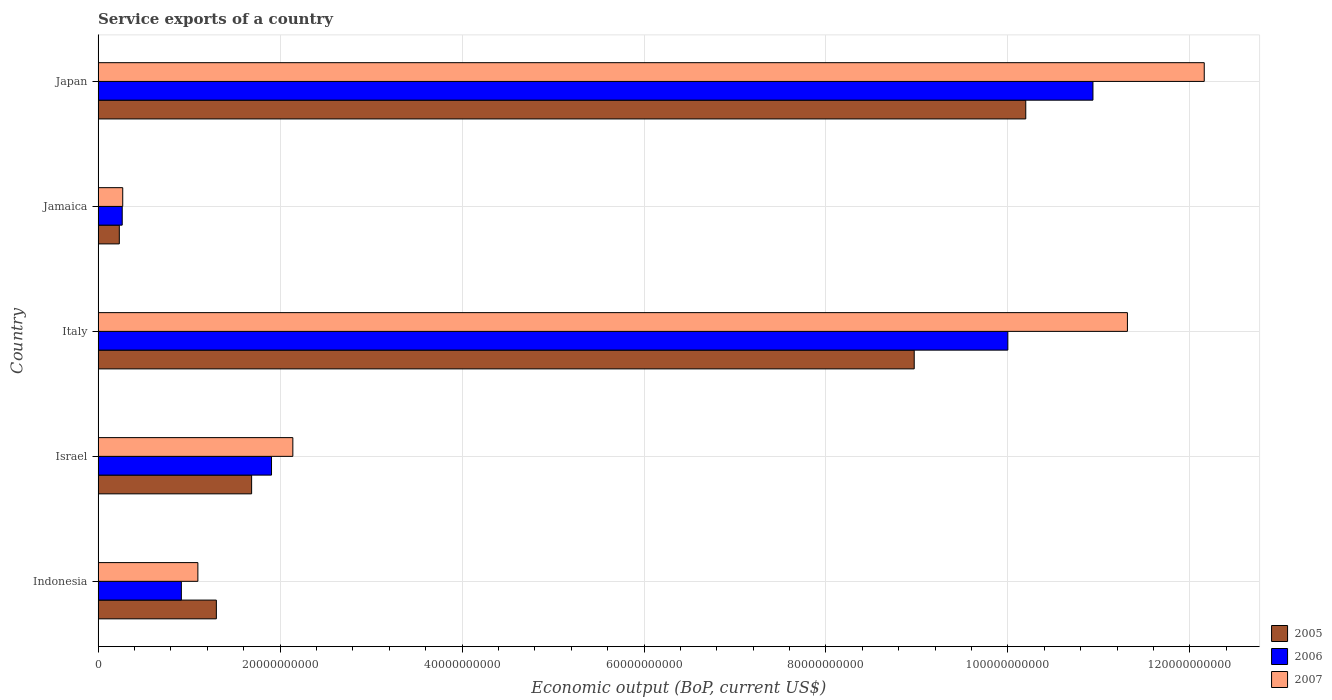How many different coloured bars are there?
Offer a very short reply. 3. Are the number of bars per tick equal to the number of legend labels?
Provide a short and direct response. Yes. Are the number of bars on each tick of the Y-axis equal?
Provide a succinct answer. Yes. How many bars are there on the 3rd tick from the top?
Give a very brief answer. 3. What is the label of the 2nd group of bars from the top?
Give a very brief answer. Jamaica. In how many cases, is the number of bars for a given country not equal to the number of legend labels?
Your answer should be very brief. 0. What is the service exports in 2005 in Japan?
Make the answer very short. 1.02e+11. Across all countries, what is the maximum service exports in 2005?
Ensure brevity in your answer.  1.02e+11. Across all countries, what is the minimum service exports in 2006?
Provide a succinct answer. 2.65e+09. In which country was the service exports in 2005 minimum?
Your response must be concise. Jamaica. What is the total service exports in 2005 in the graph?
Make the answer very short. 2.24e+11. What is the difference between the service exports in 2007 in Italy and that in Jamaica?
Offer a terse response. 1.10e+11. What is the difference between the service exports in 2006 in Israel and the service exports in 2007 in Italy?
Offer a very short reply. -9.41e+1. What is the average service exports in 2007 per country?
Your response must be concise. 5.40e+1. What is the difference between the service exports in 2006 and service exports in 2007 in Italy?
Offer a very short reply. -1.31e+1. What is the ratio of the service exports in 2005 in Indonesia to that in Israel?
Your answer should be very brief. 0.77. Is the service exports in 2006 in Israel less than that in Jamaica?
Offer a very short reply. No. Is the difference between the service exports in 2006 in Israel and Japan greater than the difference between the service exports in 2007 in Israel and Japan?
Give a very brief answer. Yes. What is the difference between the highest and the second highest service exports in 2007?
Your answer should be very brief. 8.44e+09. What is the difference between the highest and the lowest service exports in 2005?
Make the answer very short. 9.96e+1. In how many countries, is the service exports in 2005 greater than the average service exports in 2005 taken over all countries?
Keep it short and to the point. 2. Is the sum of the service exports in 2007 in Israel and Italy greater than the maximum service exports in 2006 across all countries?
Keep it short and to the point. Yes. What does the 3rd bar from the bottom in Japan represents?
Make the answer very short. 2007. Is it the case that in every country, the sum of the service exports in 2005 and service exports in 2007 is greater than the service exports in 2006?
Keep it short and to the point. Yes. How many bars are there?
Keep it short and to the point. 15. How many countries are there in the graph?
Ensure brevity in your answer.  5. What is the difference between two consecutive major ticks on the X-axis?
Make the answer very short. 2.00e+1. Are the values on the major ticks of X-axis written in scientific E-notation?
Ensure brevity in your answer.  No. Where does the legend appear in the graph?
Your answer should be very brief. Bottom right. How many legend labels are there?
Ensure brevity in your answer.  3. What is the title of the graph?
Your response must be concise. Service exports of a country. Does "1994" appear as one of the legend labels in the graph?
Your answer should be very brief. No. What is the label or title of the X-axis?
Provide a short and direct response. Economic output (BoP, current US$). What is the label or title of the Y-axis?
Your response must be concise. Country. What is the Economic output (BoP, current US$) of 2005 in Indonesia?
Your answer should be compact. 1.30e+1. What is the Economic output (BoP, current US$) in 2006 in Indonesia?
Give a very brief answer. 9.15e+09. What is the Economic output (BoP, current US$) of 2007 in Indonesia?
Ensure brevity in your answer.  1.10e+1. What is the Economic output (BoP, current US$) in 2005 in Israel?
Your answer should be very brief. 1.69e+1. What is the Economic output (BoP, current US$) of 2006 in Israel?
Give a very brief answer. 1.91e+1. What is the Economic output (BoP, current US$) of 2007 in Israel?
Offer a terse response. 2.14e+1. What is the Economic output (BoP, current US$) in 2005 in Italy?
Offer a very short reply. 8.97e+1. What is the Economic output (BoP, current US$) in 2006 in Italy?
Make the answer very short. 1.00e+11. What is the Economic output (BoP, current US$) in 2007 in Italy?
Keep it short and to the point. 1.13e+11. What is the Economic output (BoP, current US$) in 2005 in Jamaica?
Provide a succinct answer. 2.33e+09. What is the Economic output (BoP, current US$) in 2006 in Jamaica?
Provide a short and direct response. 2.65e+09. What is the Economic output (BoP, current US$) of 2007 in Jamaica?
Offer a very short reply. 2.71e+09. What is the Economic output (BoP, current US$) in 2005 in Japan?
Keep it short and to the point. 1.02e+11. What is the Economic output (BoP, current US$) in 2006 in Japan?
Your response must be concise. 1.09e+11. What is the Economic output (BoP, current US$) in 2007 in Japan?
Give a very brief answer. 1.22e+11. Across all countries, what is the maximum Economic output (BoP, current US$) of 2005?
Make the answer very short. 1.02e+11. Across all countries, what is the maximum Economic output (BoP, current US$) in 2006?
Your response must be concise. 1.09e+11. Across all countries, what is the maximum Economic output (BoP, current US$) of 2007?
Make the answer very short. 1.22e+11. Across all countries, what is the minimum Economic output (BoP, current US$) in 2005?
Your response must be concise. 2.33e+09. Across all countries, what is the minimum Economic output (BoP, current US$) of 2006?
Provide a succinct answer. 2.65e+09. Across all countries, what is the minimum Economic output (BoP, current US$) of 2007?
Make the answer very short. 2.71e+09. What is the total Economic output (BoP, current US$) in 2005 in the graph?
Your answer should be very brief. 2.24e+11. What is the total Economic output (BoP, current US$) in 2006 in the graph?
Provide a succinct answer. 2.40e+11. What is the total Economic output (BoP, current US$) in 2007 in the graph?
Provide a succinct answer. 2.70e+11. What is the difference between the Economic output (BoP, current US$) in 2005 in Indonesia and that in Israel?
Offer a terse response. -3.88e+09. What is the difference between the Economic output (BoP, current US$) in 2006 in Indonesia and that in Israel?
Keep it short and to the point. -9.91e+09. What is the difference between the Economic output (BoP, current US$) in 2007 in Indonesia and that in Israel?
Your answer should be very brief. -1.04e+1. What is the difference between the Economic output (BoP, current US$) of 2005 in Indonesia and that in Italy?
Provide a succinct answer. -7.67e+1. What is the difference between the Economic output (BoP, current US$) in 2006 in Indonesia and that in Italy?
Keep it short and to the point. -9.08e+1. What is the difference between the Economic output (BoP, current US$) in 2007 in Indonesia and that in Italy?
Your response must be concise. -1.02e+11. What is the difference between the Economic output (BoP, current US$) of 2005 in Indonesia and that in Jamaica?
Make the answer very short. 1.07e+1. What is the difference between the Economic output (BoP, current US$) of 2006 in Indonesia and that in Jamaica?
Make the answer very short. 6.50e+09. What is the difference between the Economic output (BoP, current US$) of 2007 in Indonesia and that in Jamaica?
Provide a succinct answer. 8.26e+09. What is the difference between the Economic output (BoP, current US$) in 2005 in Indonesia and that in Japan?
Offer a very short reply. -8.90e+1. What is the difference between the Economic output (BoP, current US$) of 2006 in Indonesia and that in Japan?
Give a very brief answer. -1.00e+11. What is the difference between the Economic output (BoP, current US$) in 2007 in Indonesia and that in Japan?
Provide a succinct answer. -1.11e+11. What is the difference between the Economic output (BoP, current US$) in 2005 in Israel and that in Italy?
Ensure brevity in your answer.  -7.28e+1. What is the difference between the Economic output (BoP, current US$) of 2006 in Israel and that in Italy?
Keep it short and to the point. -8.09e+1. What is the difference between the Economic output (BoP, current US$) of 2007 in Israel and that in Italy?
Give a very brief answer. -9.17e+1. What is the difference between the Economic output (BoP, current US$) of 2005 in Israel and that in Jamaica?
Your answer should be compact. 1.45e+1. What is the difference between the Economic output (BoP, current US$) in 2006 in Israel and that in Jamaica?
Your answer should be compact. 1.64e+1. What is the difference between the Economic output (BoP, current US$) in 2007 in Israel and that in Jamaica?
Offer a very short reply. 1.87e+1. What is the difference between the Economic output (BoP, current US$) of 2005 in Israel and that in Japan?
Make the answer very short. -8.51e+1. What is the difference between the Economic output (BoP, current US$) in 2006 in Israel and that in Japan?
Make the answer very short. -9.03e+1. What is the difference between the Economic output (BoP, current US$) of 2007 in Israel and that in Japan?
Keep it short and to the point. -1.00e+11. What is the difference between the Economic output (BoP, current US$) of 2005 in Italy and that in Jamaica?
Provide a short and direct response. 8.74e+1. What is the difference between the Economic output (BoP, current US$) of 2006 in Italy and that in Jamaica?
Provide a succinct answer. 9.73e+1. What is the difference between the Economic output (BoP, current US$) of 2007 in Italy and that in Jamaica?
Provide a short and direct response. 1.10e+11. What is the difference between the Economic output (BoP, current US$) in 2005 in Italy and that in Japan?
Offer a very short reply. -1.23e+1. What is the difference between the Economic output (BoP, current US$) of 2006 in Italy and that in Japan?
Keep it short and to the point. -9.36e+09. What is the difference between the Economic output (BoP, current US$) in 2007 in Italy and that in Japan?
Ensure brevity in your answer.  -8.44e+09. What is the difference between the Economic output (BoP, current US$) of 2005 in Jamaica and that in Japan?
Make the answer very short. -9.96e+1. What is the difference between the Economic output (BoP, current US$) in 2006 in Jamaica and that in Japan?
Your answer should be compact. -1.07e+11. What is the difference between the Economic output (BoP, current US$) in 2007 in Jamaica and that in Japan?
Your response must be concise. -1.19e+11. What is the difference between the Economic output (BoP, current US$) of 2005 in Indonesia and the Economic output (BoP, current US$) of 2006 in Israel?
Keep it short and to the point. -6.06e+09. What is the difference between the Economic output (BoP, current US$) of 2005 in Indonesia and the Economic output (BoP, current US$) of 2007 in Israel?
Offer a very short reply. -8.41e+09. What is the difference between the Economic output (BoP, current US$) of 2006 in Indonesia and the Economic output (BoP, current US$) of 2007 in Israel?
Provide a succinct answer. -1.23e+1. What is the difference between the Economic output (BoP, current US$) of 2005 in Indonesia and the Economic output (BoP, current US$) of 2006 in Italy?
Give a very brief answer. -8.70e+1. What is the difference between the Economic output (BoP, current US$) in 2005 in Indonesia and the Economic output (BoP, current US$) in 2007 in Italy?
Offer a very short reply. -1.00e+11. What is the difference between the Economic output (BoP, current US$) of 2006 in Indonesia and the Economic output (BoP, current US$) of 2007 in Italy?
Your response must be concise. -1.04e+11. What is the difference between the Economic output (BoP, current US$) of 2005 in Indonesia and the Economic output (BoP, current US$) of 2006 in Jamaica?
Offer a terse response. 1.03e+1. What is the difference between the Economic output (BoP, current US$) of 2005 in Indonesia and the Economic output (BoP, current US$) of 2007 in Jamaica?
Provide a succinct answer. 1.03e+1. What is the difference between the Economic output (BoP, current US$) in 2006 in Indonesia and the Economic output (BoP, current US$) in 2007 in Jamaica?
Your answer should be very brief. 6.44e+09. What is the difference between the Economic output (BoP, current US$) of 2005 in Indonesia and the Economic output (BoP, current US$) of 2006 in Japan?
Your answer should be compact. -9.63e+1. What is the difference between the Economic output (BoP, current US$) of 2005 in Indonesia and the Economic output (BoP, current US$) of 2007 in Japan?
Your answer should be very brief. -1.09e+11. What is the difference between the Economic output (BoP, current US$) in 2006 in Indonesia and the Economic output (BoP, current US$) in 2007 in Japan?
Provide a succinct answer. -1.12e+11. What is the difference between the Economic output (BoP, current US$) of 2005 in Israel and the Economic output (BoP, current US$) of 2006 in Italy?
Ensure brevity in your answer.  -8.31e+1. What is the difference between the Economic output (BoP, current US$) of 2005 in Israel and the Economic output (BoP, current US$) of 2007 in Italy?
Your answer should be compact. -9.63e+1. What is the difference between the Economic output (BoP, current US$) of 2006 in Israel and the Economic output (BoP, current US$) of 2007 in Italy?
Your answer should be compact. -9.41e+1. What is the difference between the Economic output (BoP, current US$) of 2005 in Israel and the Economic output (BoP, current US$) of 2006 in Jamaica?
Provide a short and direct response. 1.42e+1. What is the difference between the Economic output (BoP, current US$) in 2005 in Israel and the Economic output (BoP, current US$) in 2007 in Jamaica?
Ensure brevity in your answer.  1.42e+1. What is the difference between the Economic output (BoP, current US$) in 2006 in Israel and the Economic output (BoP, current US$) in 2007 in Jamaica?
Provide a succinct answer. 1.64e+1. What is the difference between the Economic output (BoP, current US$) in 2005 in Israel and the Economic output (BoP, current US$) in 2006 in Japan?
Ensure brevity in your answer.  -9.25e+1. What is the difference between the Economic output (BoP, current US$) of 2005 in Israel and the Economic output (BoP, current US$) of 2007 in Japan?
Offer a very short reply. -1.05e+11. What is the difference between the Economic output (BoP, current US$) of 2006 in Israel and the Economic output (BoP, current US$) of 2007 in Japan?
Provide a short and direct response. -1.03e+11. What is the difference between the Economic output (BoP, current US$) of 2005 in Italy and the Economic output (BoP, current US$) of 2006 in Jamaica?
Your answer should be compact. 8.71e+1. What is the difference between the Economic output (BoP, current US$) of 2005 in Italy and the Economic output (BoP, current US$) of 2007 in Jamaica?
Provide a short and direct response. 8.70e+1. What is the difference between the Economic output (BoP, current US$) in 2006 in Italy and the Economic output (BoP, current US$) in 2007 in Jamaica?
Your response must be concise. 9.73e+1. What is the difference between the Economic output (BoP, current US$) in 2005 in Italy and the Economic output (BoP, current US$) in 2006 in Japan?
Offer a very short reply. -1.96e+1. What is the difference between the Economic output (BoP, current US$) of 2005 in Italy and the Economic output (BoP, current US$) of 2007 in Japan?
Offer a very short reply. -3.19e+1. What is the difference between the Economic output (BoP, current US$) in 2006 in Italy and the Economic output (BoP, current US$) in 2007 in Japan?
Provide a succinct answer. -2.16e+1. What is the difference between the Economic output (BoP, current US$) of 2005 in Jamaica and the Economic output (BoP, current US$) of 2006 in Japan?
Provide a short and direct response. -1.07e+11. What is the difference between the Economic output (BoP, current US$) in 2005 in Jamaica and the Economic output (BoP, current US$) in 2007 in Japan?
Your response must be concise. -1.19e+11. What is the difference between the Economic output (BoP, current US$) in 2006 in Jamaica and the Economic output (BoP, current US$) in 2007 in Japan?
Your answer should be very brief. -1.19e+11. What is the average Economic output (BoP, current US$) in 2005 per country?
Provide a short and direct response. 4.48e+1. What is the average Economic output (BoP, current US$) of 2006 per country?
Provide a succinct answer. 4.80e+1. What is the average Economic output (BoP, current US$) of 2007 per country?
Give a very brief answer. 5.40e+1. What is the difference between the Economic output (BoP, current US$) in 2005 and Economic output (BoP, current US$) in 2006 in Indonesia?
Provide a succinct answer. 3.85e+09. What is the difference between the Economic output (BoP, current US$) in 2005 and Economic output (BoP, current US$) in 2007 in Indonesia?
Offer a terse response. 2.03e+09. What is the difference between the Economic output (BoP, current US$) in 2006 and Economic output (BoP, current US$) in 2007 in Indonesia?
Offer a very short reply. -1.82e+09. What is the difference between the Economic output (BoP, current US$) of 2005 and Economic output (BoP, current US$) of 2006 in Israel?
Keep it short and to the point. -2.19e+09. What is the difference between the Economic output (BoP, current US$) in 2005 and Economic output (BoP, current US$) in 2007 in Israel?
Give a very brief answer. -4.53e+09. What is the difference between the Economic output (BoP, current US$) in 2006 and Economic output (BoP, current US$) in 2007 in Israel?
Your answer should be very brief. -2.34e+09. What is the difference between the Economic output (BoP, current US$) of 2005 and Economic output (BoP, current US$) of 2006 in Italy?
Keep it short and to the point. -1.03e+1. What is the difference between the Economic output (BoP, current US$) of 2005 and Economic output (BoP, current US$) of 2007 in Italy?
Your answer should be compact. -2.34e+1. What is the difference between the Economic output (BoP, current US$) in 2006 and Economic output (BoP, current US$) in 2007 in Italy?
Offer a very short reply. -1.31e+1. What is the difference between the Economic output (BoP, current US$) of 2005 and Economic output (BoP, current US$) of 2006 in Jamaica?
Provide a succinct answer. -3.19e+08. What is the difference between the Economic output (BoP, current US$) in 2005 and Economic output (BoP, current US$) in 2007 in Jamaica?
Keep it short and to the point. -3.77e+08. What is the difference between the Economic output (BoP, current US$) of 2006 and Economic output (BoP, current US$) of 2007 in Jamaica?
Ensure brevity in your answer.  -5.79e+07. What is the difference between the Economic output (BoP, current US$) in 2005 and Economic output (BoP, current US$) in 2006 in Japan?
Provide a short and direct response. -7.38e+09. What is the difference between the Economic output (BoP, current US$) of 2005 and Economic output (BoP, current US$) of 2007 in Japan?
Your response must be concise. -1.96e+1. What is the difference between the Economic output (BoP, current US$) in 2006 and Economic output (BoP, current US$) in 2007 in Japan?
Offer a terse response. -1.22e+1. What is the ratio of the Economic output (BoP, current US$) of 2005 in Indonesia to that in Israel?
Make the answer very short. 0.77. What is the ratio of the Economic output (BoP, current US$) of 2006 in Indonesia to that in Israel?
Provide a succinct answer. 0.48. What is the ratio of the Economic output (BoP, current US$) of 2007 in Indonesia to that in Israel?
Your answer should be compact. 0.51. What is the ratio of the Economic output (BoP, current US$) of 2005 in Indonesia to that in Italy?
Give a very brief answer. 0.14. What is the ratio of the Economic output (BoP, current US$) in 2006 in Indonesia to that in Italy?
Offer a very short reply. 0.09. What is the ratio of the Economic output (BoP, current US$) in 2007 in Indonesia to that in Italy?
Offer a very short reply. 0.1. What is the ratio of the Economic output (BoP, current US$) in 2005 in Indonesia to that in Jamaica?
Ensure brevity in your answer.  5.58. What is the ratio of the Economic output (BoP, current US$) of 2006 in Indonesia to that in Jamaica?
Provide a short and direct response. 3.45. What is the ratio of the Economic output (BoP, current US$) of 2007 in Indonesia to that in Jamaica?
Your answer should be compact. 4.05. What is the ratio of the Economic output (BoP, current US$) of 2005 in Indonesia to that in Japan?
Give a very brief answer. 0.13. What is the ratio of the Economic output (BoP, current US$) of 2006 in Indonesia to that in Japan?
Your response must be concise. 0.08. What is the ratio of the Economic output (BoP, current US$) in 2007 in Indonesia to that in Japan?
Offer a terse response. 0.09. What is the ratio of the Economic output (BoP, current US$) of 2005 in Israel to that in Italy?
Your response must be concise. 0.19. What is the ratio of the Economic output (BoP, current US$) of 2006 in Israel to that in Italy?
Give a very brief answer. 0.19. What is the ratio of the Economic output (BoP, current US$) in 2007 in Israel to that in Italy?
Your response must be concise. 0.19. What is the ratio of the Economic output (BoP, current US$) of 2005 in Israel to that in Jamaica?
Ensure brevity in your answer.  7.24. What is the ratio of the Economic output (BoP, current US$) of 2006 in Israel to that in Jamaica?
Offer a very short reply. 7.2. What is the ratio of the Economic output (BoP, current US$) in 2007 in Israel to that in Jamaica?
Offer a very short reply. 7.91. What is the ratio of the Economic output (BoP, current US$) in 2005 in Israel to that in Japan?
Offer a terse response. 0.17. What is the ratio of the Economic output (BoP, current US$) of 2006 in Israel to that in Japan?
Provide a succinct answer. 0.17. What is the ratio of the Economic output (BoP, current US$) of 2007 in Israel to that in Japan?
Your answer should be very brief. 0.18. What is the ratio of the Economic output (BoP, current US$) in 2005 in Italy to that in Jamaica?
Provide a short and direct response. 38.5. What is the ratio of the Economic output (BoP, current US$) of 2006 in Italy to that in Jamaica?
Make the answer very short. 37.75. What is the ratio of the Economic output (BoP, current US$) in 2007 in Italy to that in Jamaica?
Your response must be concise. 41.8. What is the ratio of the Economic output (BoP, current US$) in 2005 in Italy to that in Japan?
Your response must be concise. 0.88. What is the ratio of the Economic output (BoP, current US$) of 2006 in Italy to that in Japan?
Your answer should be compact. 0.91. What is the ratio of the Economic output (BoP, current US$) of 2007 in Italy to that in Japan?
Your response must be concise. 0.93. What is the ratio of the Economic output (BoP, current US$) of 2005 in Jamaica to that in Japan?
Offer a very short reply. 0.02. What is the ratio of the Economic output (BoP, current US$) in 2006 in Jamaica to that in Japan?
Keep it short and to the point. 0.02. What is the ratio of the Economic output (BoP, current US$) in 2007 in Jamaica to that in Japan?
Offer a very short reply. 0.02. What is the difference between the highest and the second highest Economic output (BoP, current US$) in 2005?
Your answer should be compact. 1.23e+1. What is the difference between the highest and the second highest Economic output (BoP, current US$) in 2006?
Offer a terse response. 9.36e+09. What is the difference between the highest and the second highest Economic output (BoP, current US$) in 2007?
Offer a very short reply. 8.44e+09. What is the difference between the highest and the lowest Economic output (BoP, current US$) in 2005?
Offer a terse response. 9.96e+1. What is the difference between the highest and the lowest Economic output (BoP, current US$) of 2006?
Keep it short and to the point. 1.07e+11. What is the difference between the highest and the lowest Economic output (BoP, current US$) in 2007?
Your answer should be very brief. 1.19e+11. 